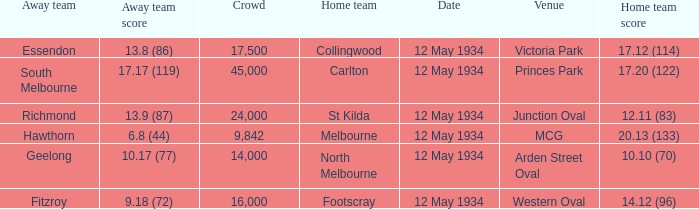What was the score of the away team while playing at the arden street oval? 10.17 (77). 